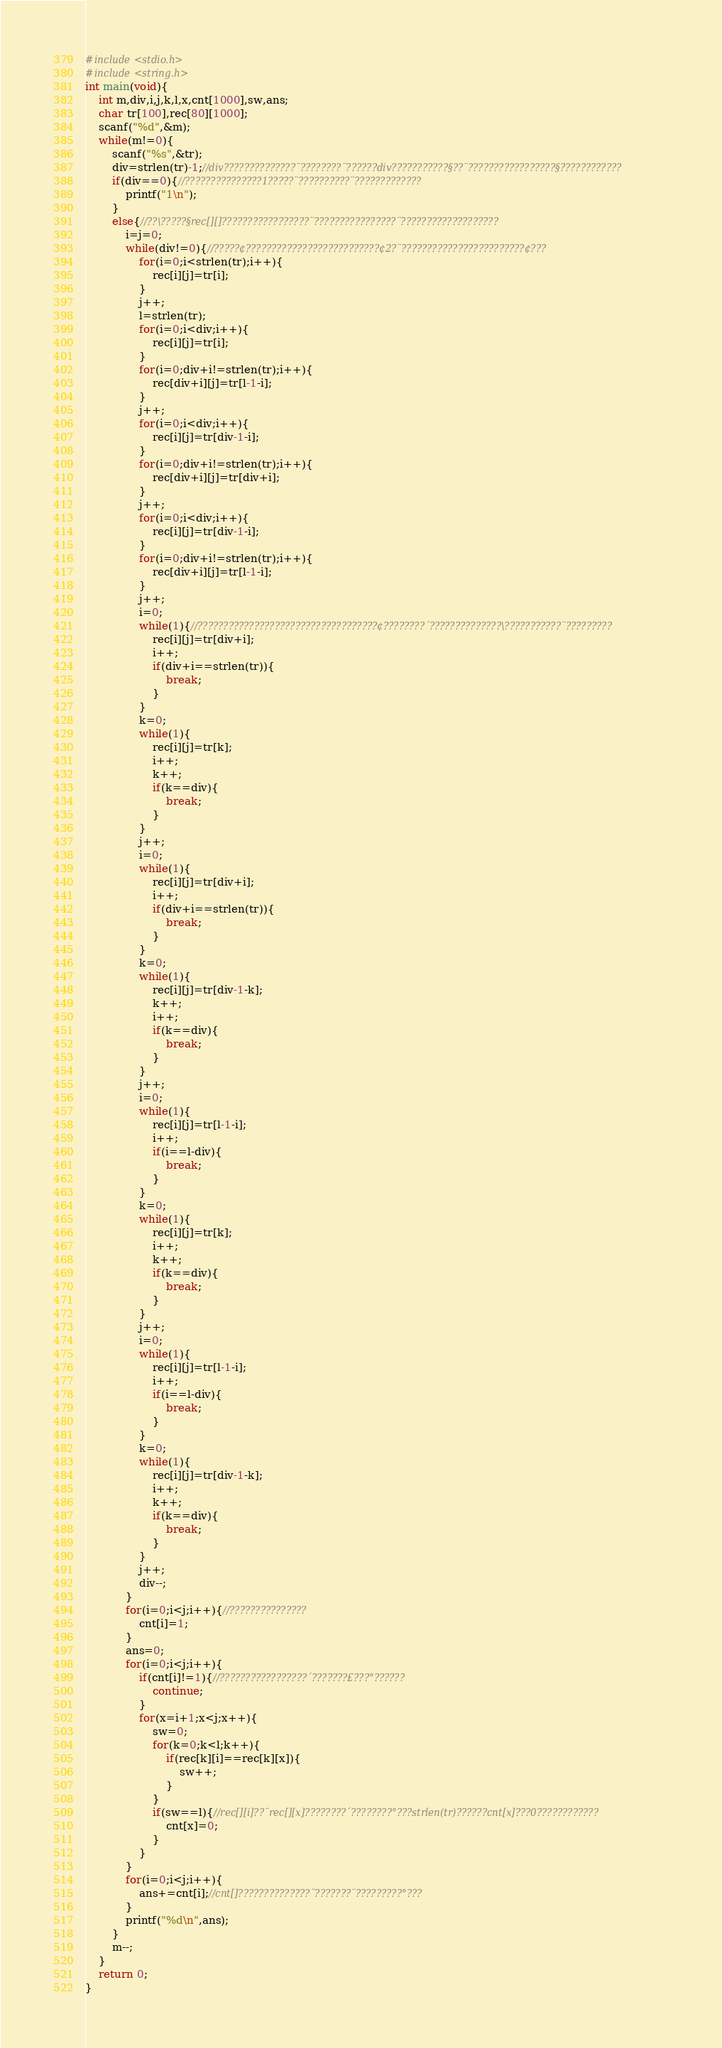Convert code to text. <code><loc_0><loc_0><loc_500><loc_500><_C_>#include<stdio.h>
#include<string.h>
int main(void){
	int m,div,i,j,k,l,x,cnt[1000],sw,ans;
	char tr[100],rec[80][1000];
	scanf("%d",&m);
	while(m!=0){
		scanf("%s",&tr);
		div=strlen(tr)-1;//div??????????????¨????????¨??????div???????????§??¨?????????????????§????????????
		if(div==0){//???????????????1?????¨??????????¨?????????????
			printf("1\n");
		}
		else{//??\?????§rec[][]?????????????????¨????????????????¨???????????????????
			i=j=0;
			while(div!=0){//?????¢??????????????????????????¢2?¨????????????????????????¢???
				for(i=0;i<strlen(tr);i++){
					rec[i][j]=tr[i];
				}
				j++;
				l=strlen(tr);
				for(i=0;i<div;i++){
					rec[i][j]=tr[i];
				}
				for(i=0;div+i!=strlen(tr);i++){
					rec[div+i][j]=tr[l-1-i];
				}
				j++;
				for(i=0;i<div;i++){
					rec[i][j]=tr[div-1-i];
				}
				for(i=0;div+i!=strlen(tr);i++){
					rec[div+i][j]=tr[div+i];
				}
				j++;
				for(i=0;i<div;i++){
					rec[i][j]=tr[div-1-i];
				}
				for(i=0;div+i!=strlen(tr);i++){
					rec[div+i][j]=tr[l-1-i];
				}
				j++;
				i=0;
				while(1){//???????????????????????????????????¢????????´??????????????\???????????¨?????????
					rec[i][j]=tr[div+i];
					i++;
					if(div+i==strlen(tr)){
						break;
					}
				}
				k=0;
				while(1){
					rec[i][j]=tr[k];
					i++;
					k++;
					if(k==div){
						break;
					}
				}
				j++;
				i=0;
				while(1){
					rec[i][j]=tr[div+i];
					i++;
					if(div+i==strlen(tr)){
						break;
					}
				}
				k=0;
				while(1){
					rec[i][j]=tr[div-1-k];
					k++;
					i++;
					if(k==div){
						break;
					}
				}
				j++;
				i=0;
				while(1){
					rec[i][j]=tr[l-1-i];
					i++;
					if(i==l-div){
						break;
					}
				}
				k=0;
				while(1){
					rec[i][j]=tr[k];
					i++;
					k++;
					if(k==div){
						break;
					}
				}
				j++;
				i=0;
				while(1){
					rec[i][j]=tr[l-1-i];
					i++;
					if(i==l-div){
						break;
					}
				}
				k=0;
				while(1){
					rec[i][j]=tr[div-1-k];
					i++;
					k++;
					if(k==div){
						break;
					}
				}
				j++;
				div--;
			}
			for(i=0;i<j;i++){//???????????????
				cnt[i]=1;
			}
			ans=0;
			for(i=0;i<j;i++){
				if(cnt[i]!=1){//?????????????????´???????£???°??????
					continue;
				}
				for(x=i+1;x<j;x++){
					sw=0;
					for(k=0;k<l;k++){
						if(rec[k][i]==rec[k][x]){
							sw++;
						}
					}
					if(sw==l){//rec[][i]??¨rec[][x]????????´????????°???strlen(tr)??????cnt[x]???0????????????
						cnt[x]=0;
					}
				}
			}
			for(i=0;i<j;i++){
				ans+=cnt[i];//cnt[]??????????????¨???????¨?????????°???
			}
			printf("%d\n",ans);
		}
		m--;
	}
	return 0;
}</code> 